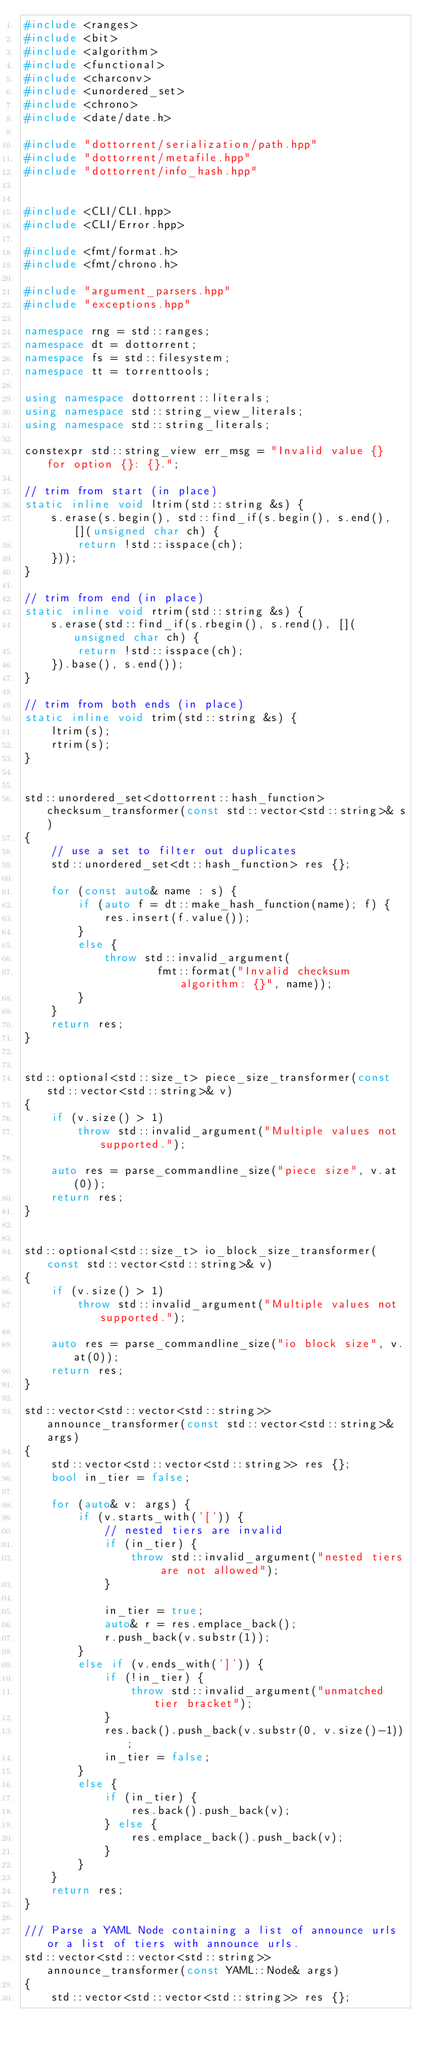<code> <loc_0><loc_0><loc_500><loc_500><_C++_>#include <ranges>
#include <bit>
#include <algorithm>
#include <functional>
#include <charconv>
#include <unordered_set>
#include <chrono>
#include <date/date.h>

#include "dottorrent/serialization/path.hpp"
#include "dottorrent/metafile.hpp"
#include "dottorrent/info_hash.hpp"


#include <CLI/CLI.hpp>
#include <CLI/Error.hpp>

#include <fmt/format.h>
#include <fmt/chrono.h>

#include "argument_parsers.hpp"
#include "exceptions.hpp"

namespace rng = std::ranges;
namespace dt = dottorrent;
namespace fs = std::filesystem;
namespace tt = torrenttools;

using namespace dottorrent::literals;
using namespace std::string_view_literals;
using namespace std::string_literals;

constexpr std::string_view err_msg = "Invalid value {} for option {}: {}.";

// trim from start (in place)
static inline void ltrim(std::string &s) {
    s.erase(s.begin(), std::find_if(s.begin(), s.end(), [](unsigned char ch) {
        return !std::isspace(ch);
    }));
}

// trim from end (in place)
static inline void rtrim(std::string &s) {
    s.erase(std::find_if(s.rbegin(), s.rend(), [](unsigned char ch) {
        return !std::isspace(ch);
    }).base(), s.end());
}

// trim from both ends (in place)
static inline void trim(std::string &s) {
    ltrim(s);
    rtrim(s);
}


std::unordered_set<dottorrent::hash_function> checksum_transformer(const std::vector<std::string>& s)
{
    // use a set to filter out duplicates
    std::unordered_set<dt::hash_function> res {};

    for (const auto& name : s) {
        if (auto f = dt::make_hash_function(name); f) {
            res.insert(f.value());
        }
        else {
            throw std::invalid_argument(
                    fmt::format("Invalid checksum algorithm: {}", name));
        }
    }
    return res;
}


std::optional<std::size_t> piece_size_transformer(const std::vector<std::string>& v)
{
    if (v.size() > 1)
        throw std::invalid_argument("Multiple values not supported.");

    auto res = parse_commandline_size("piece size", v.at(0));
    return res;
}


std::optional<std::size_t> io_block_size_transformer(const std::vector<std::string>& v)
{
    if (v.size() > 1)
        throw std::invalid_argument("Multiple values not supported.");

    auto res = parse_commandline_size("io block size", v.at(0));
    return res;
}

std::vector<std::vector<std::string>> announce_transformer(const std::vector<std::string>& args)
{
    std::vector<std::vector<std::string>> res {};
    bool in_tier = false;

    for (auto& v: args) {
        if (v.starts_with('[')) {
            // nested tiers are invalid
            if (in_tier) {
                throw std::invalid_argument("nested tiers are not allowed");
            }

            in_tier = true;
            auto& r = res.emplace_back();
            r.push_back(v.substr(1));
        }
        else if (v.ends_with(']')) {
            if (!in_tier) {
                throw std::invalid_argument("unmatched tier bracket");
            }
            res.back().push_back(v.substr(0, v.size()-1));
            in_tier = false;
        }
        else {
            if (in_tier) {
                res.back().push_back(v);
            } else {
                res.emplace_back().push_back(v);
            }
        }
    }
    return res;
}

/// Parse a YAML Node containing a list of announce urls or a list of tiers with announce urls.
std::vector<std::vector<std::string>> announce_transformer(const YAML::Node& args)
{
    std::vector<std::vector<std::string>> res {};
</code> 